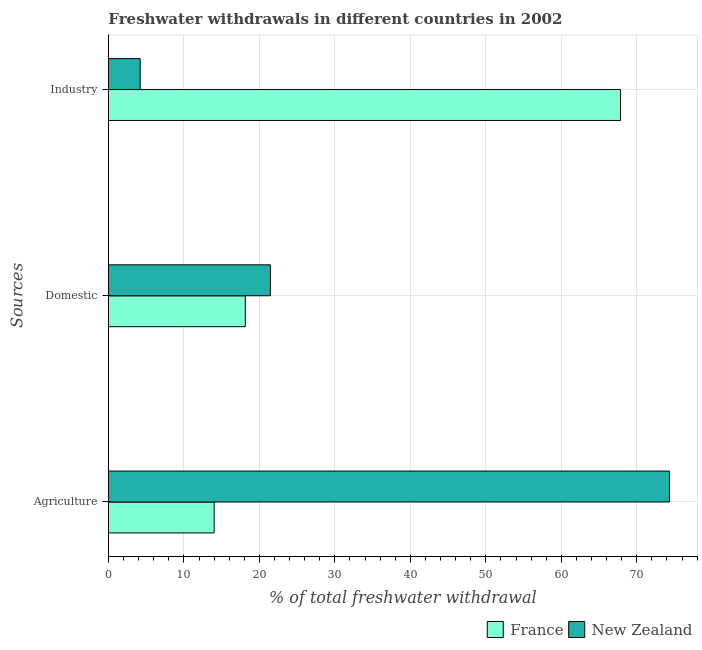How many different coloured bars are there?
Make the answer very short. 2. How many groups of bars are there?
Your response must be concise. 3. How many bars are there on the 3rd tick from the top?
Offer a very short reply. 2. How many bars are there on the 2nd tick from the bottom?
Your answer should be very brief. 2. What is the label of the 3rd group of bars from the top?
Offer a very short reply. Agriculture. What is the percentage of freshwater withdrawal for industry in France?
Make the answer very short. 67.85. Across all countries, what is the maximum percentage of freshwater withdrawal for domestic purposes?
Ensure brevity in your answer.  21.46. Across all countries, what is the minimum percentage of freshwater withdrawal for domestic purposes?
Make the answer very short. 18.13. In which country was the percentage of freshwater withdrawal for agriculture maximum?
Offer a very short reply. New Zealand. In which country was the percentage of freshwater withdrawal for domestic purposes minimum?
Offer a very short reply. France. What is the total percentage of freshwater withdrawal for domestic purposes in the graph?
Ensure brevity in your answer.  39.59. What is the difference between the percentage of freshwater withdrawal for domestic purposes in New Zealand and that in France?
Provide a short and direct response. 3.33. What is the difference between the percentage of freshwater withdrawal for agriculture in New Zealand and the percentage of freshwater withdrawal for industry in France?
Give a very brief answer. 6.48. What is the average percentage of freshwater withdrawal for agriculture per country?
Your answer should be compact. 44.17. What is the difference between the percentage of freshwater withdrawal for industry and percentage of freshwater withdrawal for agriculture in France?
Your answer should be very brief. 53.84. In how many countries, is the percentage of freshwater withdrawal for domestic purposes greater than 28 %?
Give a very brief answer. 0. What is the ratio of the percentage of freshwater withdrawal for agriculture in New Zealand to that in France?
Provide a short and direct response. 5.31. Is the percentage of freshwater withdrawal for industry in France less than that in New Zealand?
Give a very brief answer. No. Is the difference between the percentage of freshwater withdrawal for industry in France and New Zealand greater than the difference between the percentage of freshwater withdrawal for domestic purposes in France and New Zealand?
Ensure brevity in your answer.  Yes. What is the difference between the highest and the second highest percentage of freshwater withdrawal for industry?
Offer a very short reply. 63.64. What is the difference between the highest and the lowest percentage of freshwater withdrawal for agriculture?
Offer a very short reply. 60.32. In how many countries, is the percentage of freshwater withdrawal for industry greater than the average percentage of freshwater withdrawal for industry taken over all countries?
Make the answer very short. 1. Is the sum of the percentage of freshwater withdrawal for agriculture in France and New Zealand greater than the maximum percentage of freshwater withdrawal for industry across all countries?
Ensure brevity in your answer.  Yes. Is it the case that in every country, the sum of the percentage of freshwater withdrawal for agriculture and percentage of freshwater withdrawal for domestic purposes is greater than the percentage of freshwater withdrawal for industry?
Provide a short and direct response. No. Are all the bars in the graph horizontal?
Give a very brief answer. Yes. Does the graph contain any zero values?
Your answer should be compact. No. Does the graph contain grids?
Provide a short and direct response. Yes. Where does the legend appear in the graph?
Provide a succinct answer. Bottom right. How are the legend labels stacked?
Provide a short and direct response. Horizontal. What is the title of the graph?
Offer a very short reply. Freshwater withdrawals in different countries in 2002. What is the label or title of the X-axis?
Provide a short and direct response. % of total freshwater withdrawal. What is the label or title of the Y-axis?
Your answer should be very brief. Sources. What is the % of total freshwater withdrawal of France in Agriculture?
Your answer should be compact. 14.01. What is the % of total freshwater withdrawal of New Zealand in Agriculture?
Ensure brevity in your answer.  74.33. What is the % of total freshwater withdrawal of France in Domestic?
Keep it short and to the point. 18.13. What is the % of total freshwater withdrawal of New Zealand in Domestic?
Provide a short and direct response. 21.46. What is the % of total freshwater withdrawal in France in Industry?
Ensure brevity in your answer.  67.85. What is the % of total freshwater withdrawal in New Zealand in Industry?
Keep it short and to the point. 4.21. Across all Sources, what is the maximum % of total freshwater withdrawal in France?
Your answer should be compact. 67.85. Across all Sources, what is the maximum % of total freshwater withdrawal of New Zealand?
Offer a terse response. 74.33. Across all Sources, what is the minimum % of total freshwater withdrawal of France?
Make the answer very short. 14.01. Across all Sources, what is the minimum % of total freshwater withdrawal in New Zealand?
Give a very brief answer. 4.21. What is the total % of total freshwater withdrawal of France in the graph?
Keep it short and to the point. 99.99. What is the total % of total freshwater withdrawal in New Zealand in the graph?
Make the answer very short. 100. What is the difference between the % of total freshwater withdrawal of France in Agriculture and that in Domestic?
Provide a succinct answer. -4.12. What is the difference between the % of total freshwater withdrawal in New Zealand in Agriculture and that in Domestic?
Offer a very short reply. 52.87. What is the difference between the % of total freshwater withdrawal in France in Agriculture and that in Industry?
Offer a terse response. -53.84. What is the difference between the % of total freshwater withdrawal in New Zealand in Agriculture and that in Industry?
Provide a succinct answer. 70.12. What is the difference between the % of total freshwater withdrawal of France in Domestic and that in Industry?
Give a very brief answer. -49.72. What is the difference between the % of total freshwater withdrawal in New Zealand in Domestic and that in Industry?
Make the answer very short. 17.25. What is the difference between the % of total freshwater withdrawal of France in Agriculture and the % of total freshwater withdrawal of New Zealand in Domestic?
Provide a short and direct response. -7.45. What is the difference between the % of total freshwater withdrawal of France in Agriculture and the % of total freshwater withdrawal of New Zealand in Industry?
Your response must be concise. 9.8. What is the difference between the % of total freshwater withdrawal of France in Domestic and the % of total freshwater withdrawal of New Zealand in Industry?
Offer a very short reply. 13.92. What is the average % of total freshwater withdrawal in France per Sources?
Keep it short and to the point. 33.33. What is the average % of total freshwater withdrawal of New Zealand per Sources?
Offer a terse response. 33.33. What is the difference between the % of total freshwater withdrawal in France and % of total freshwater withdrawal in New Zealand in Agriculture?
Provide a succinct answer. -60.32. What is the difference between the % of total freshwater withdrawal of France and % of total freshwater withdrawal of New Zealand in Domestic?
Give a very brief answer. -3.33. What is the difference between the % of total freshwater withdrawal in France and % of total freshwater withdrawal in New Zealand in Industry?
Offer a very short reply. 63.64. What is the ratio of the % of total freshwater withdrawal in France in Agriculture to that in Domestic?
Ensure brevity in your answer.  0.77. What is the ratio of the % of total freshwater withdrawal in New Zealand in Agriculture to that in Domestic?
Your answer should be very brief. 3.46. What is the ratio of the % of total freshwater withdrawal in France in Agriculture to that in Industry?
Give a very brief answer. 0.21. What is the ratio of the % of total freshwater withdrawal in New Zealand in Agriculture to that in Industry?
Give a very brief answer. 17.66. What is the ratio of the % of total freshwater withdrawal in France in Domestic to that in Industry?
Give a very brief answer. 0.27. What is the ratio of the % of total freshwater withdrawal of New Zealand in Domestic to that in Industry?
Provide a short and direct response. 5.1. What is the difference between the highest and the second highest % of total freshwater withdrawal in France?
Provide a short and direct response. 49.72. What is the difference between the highest and the second highest % of total freshwater withdrawal in New Zealand?
Ensure brevity in your answer.  52.87. What is the difference between the highest and the lowest % of total freshwater withdrawal in France?
Your response must be concise. 53.84. What is the difference between the highest and the lowest % of total freshwater withdrawal in New Zealand?
Give a very brief answer. 70.12. 